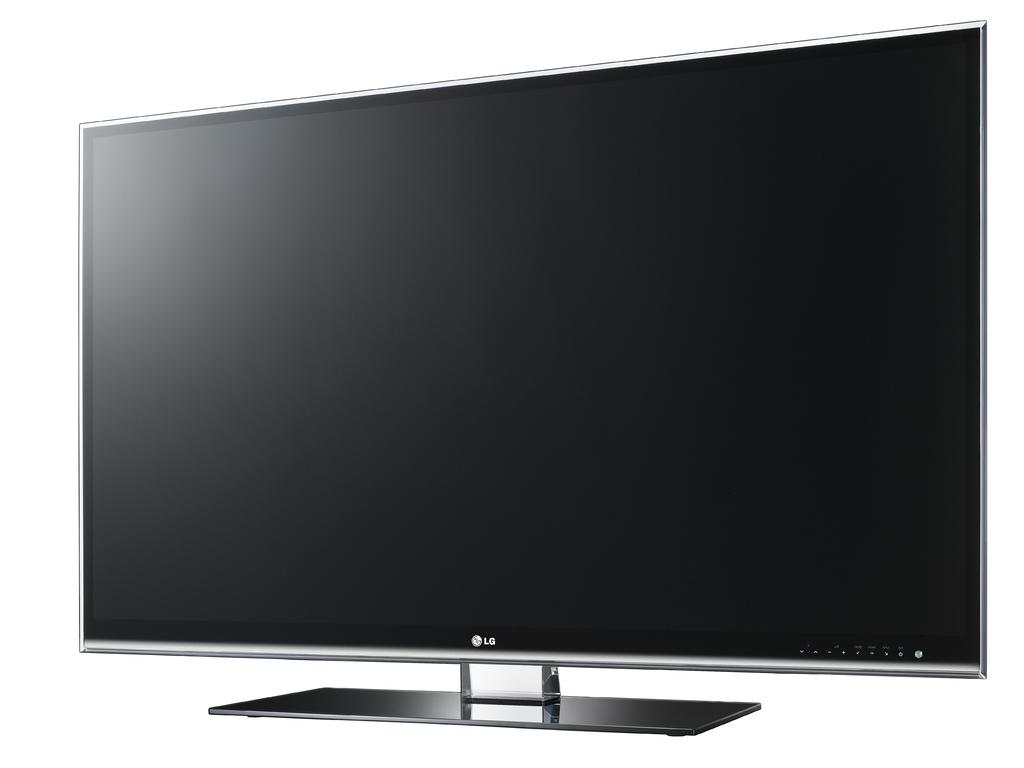<image>
Give a short and clear explanation of the subsequent image. A large LE flat screen is sitting on the table. 